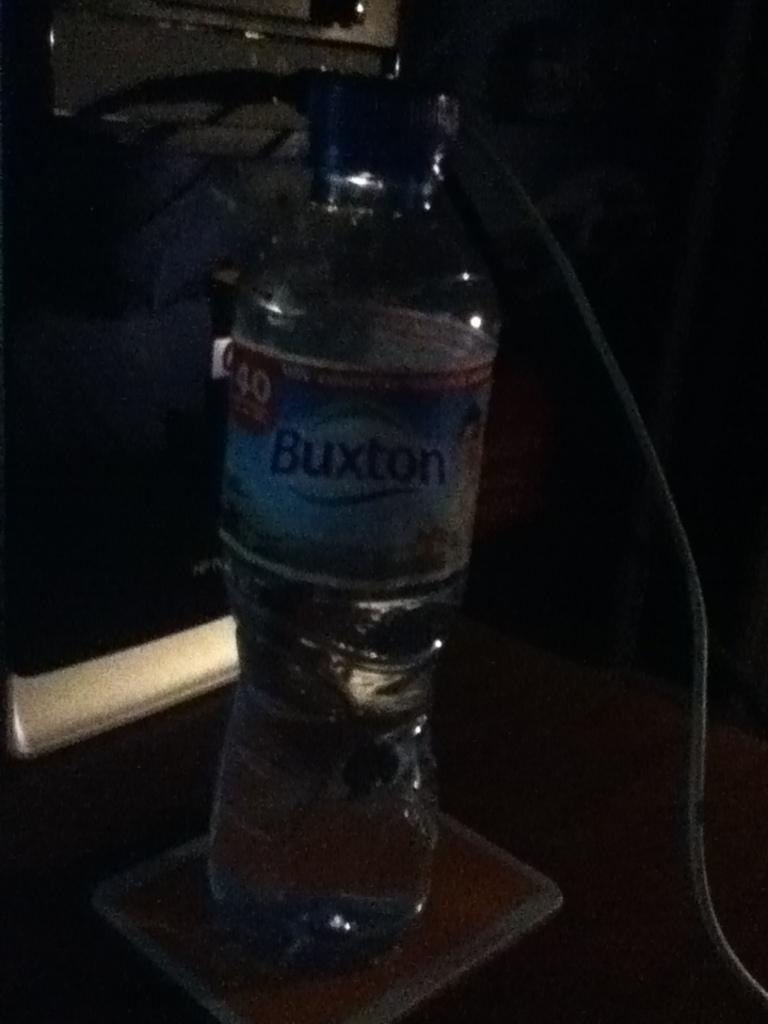<image>
Share a concise interpretation of the image provided. A bottle of Buxton water sits on a coaster 